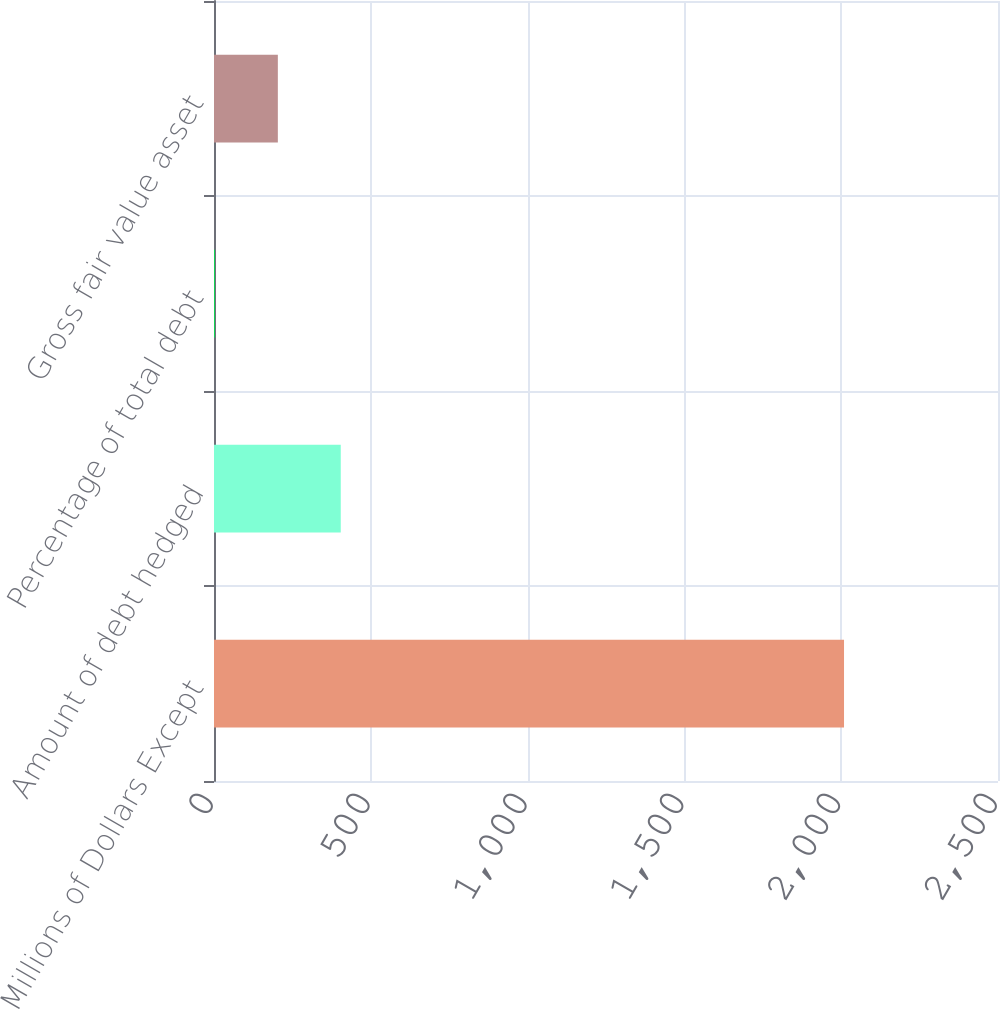<chart> <loc_0><loc_0><loc_500><loc_500><bar_chart><fcel>Millions of Dollars Except<fcel>Amount of debt hedged<fcel>Percentage of total debt<fcel>Gross fair value asset<nl><fcel>2009<fcel>404.2<fcel>3<fcel>203.6<nl></chart> 